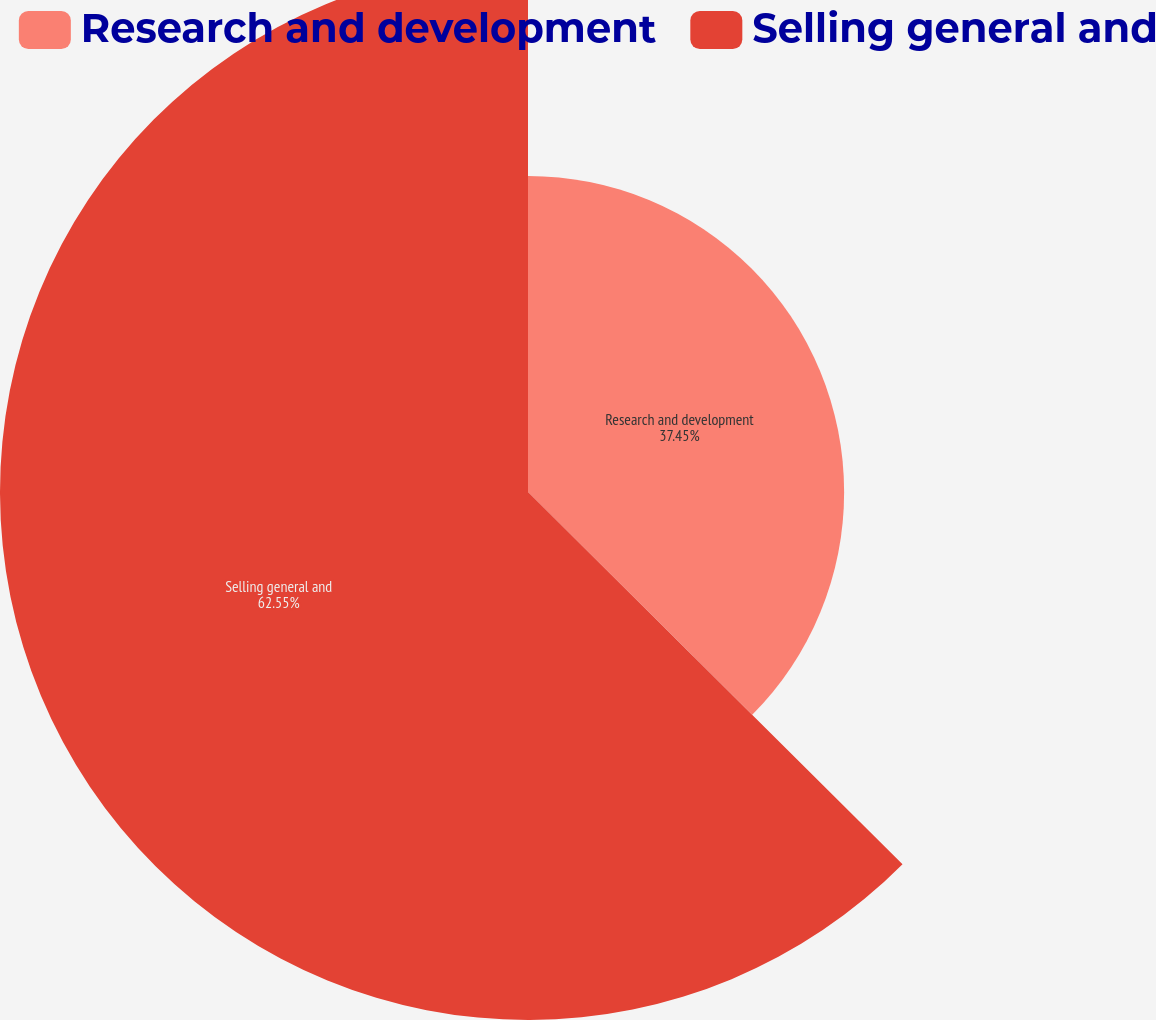Convert chart to OTSL. <chart><loc_0><loc_0><loc_500><loc_500><pie_chart><fcel>Research and development<fcel>Selling general and<nl><fcel>37.45%<fcel>62.55%<nl></chart> 